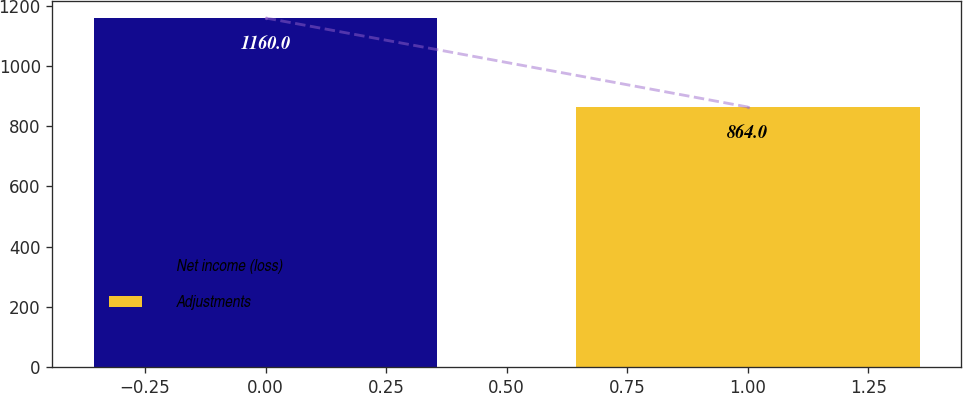<chart> <loc_0><loc_0><loc_500><loc_500><bar_chart><fcel>Net income (loss)<fcel>Adjustments<nl><fcel>1160<fcel>864<nl></chart> 